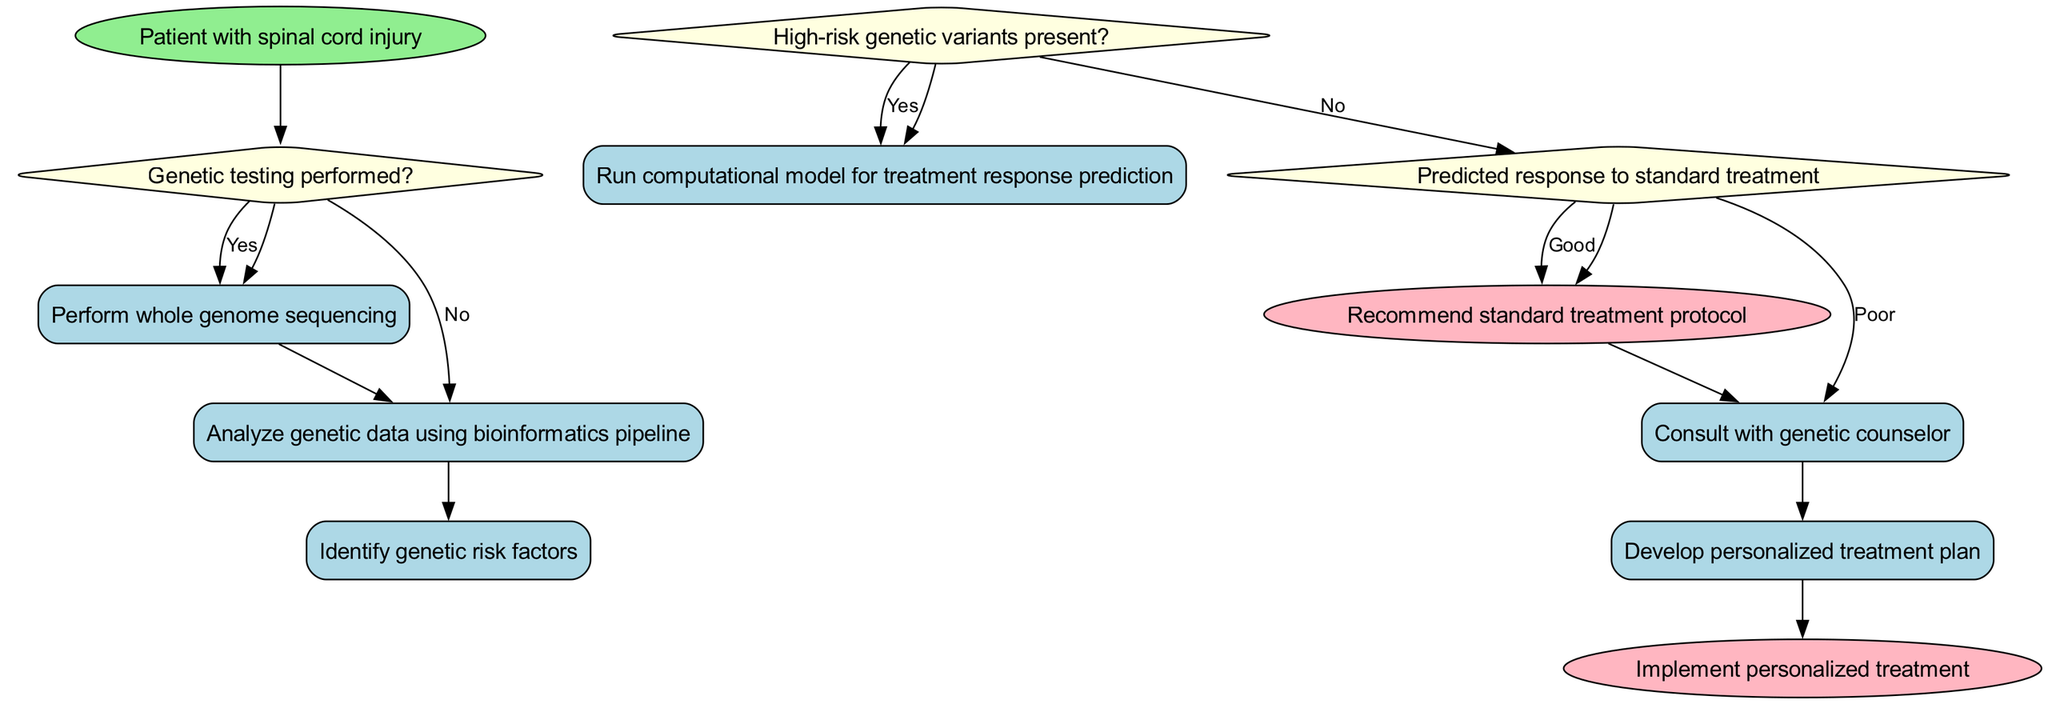What is the start node of the pathway? The start node of the pathway is labeled as "Patient with spinal cord injury." It is the initial point from which the clinical decision-making process begins.
Answer: Patient with spinal cord injury How many decision nodes are present in the diagram? The diagram contains three decision nodes: "Genetic testing performed?", "High-risk genetic variants present?", and "Predicted response to standard treatment." Counting these gives a total of three decision nodes.
Answer: Three What is the first process after genetic testing is performed? After confirming that genetic testing is performed, the first process is to "Perform whole genome sequencing," which is the immediate action following the initial decision.
Answer: Perform whole genome sequencing If high-risk genetic variants are present, what is the next action taken? If high-risk genetic variants are present, the pathway dictates that a computational model for treatment response prediction is run, which requires further analysis before proceeding to treatment recommendations.
Answer: Run computational model for treatment response prediction What outcome is recommended if the predicted response to standard treatment is good? If the predicted response to standard treatment is good, the pathway recommends to "Recommend standard treatment protocol," indicating that typical treatment will be suggested without further personalization.
Answer: Recommend standard treatment protocol What is the final endpoint of the diagram after implementing the personalized treatment? The final endpoint of the clinical pathway, after all previous processes and consultations, is "Implement personalized treatment," which signifies the conclusion of the pathway's decision-making process.
Answer: Implement personalized treatment How many processes are listed in the diagram? There are five process nodes listed in the diagram: "Perform whole genome sequencing," "Analyze genetic data using bioinformatics pipeline," "Identify genetic risk factors," "Run computational model for treatment response prediction," and "Develop personalized treatment plan." Counting these gives a total of five processes.
Answer: Five What does the diagram require before developing a personalized treatment plan? Before developing a personalized treatment plan, the diagram requires consultation with a genetic counselor following the identification of any high-risk genetic variants present. This indicates the need for expert guidance in the treatment plan formulation.
Answer: Consult with genetic counselor 